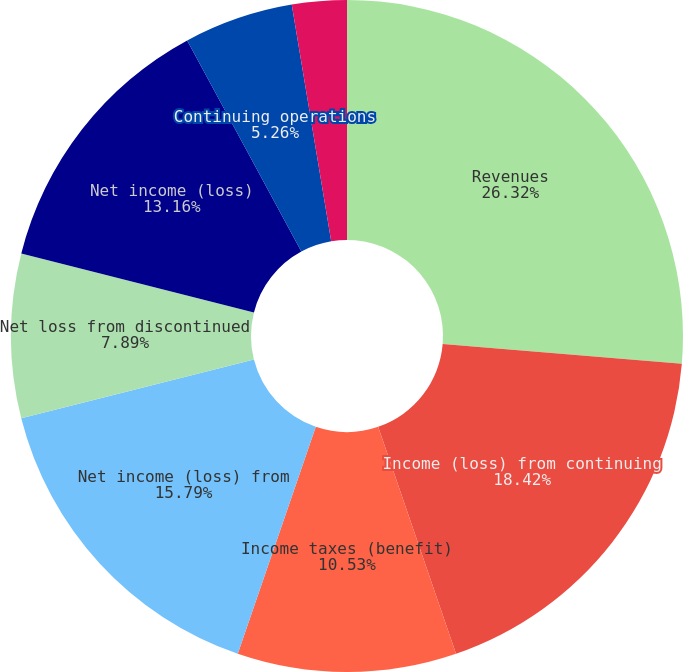Convert chart to OTSL. <chart><loc_0><loc_0><loc_500><loc_500><pie_chart><fcel>Revenues<fcel>Income (loss) from continuing<fcel>Income taxes (benefit)<fcel>Net income (loss) from<fcel>Net loss from discontinued<fcel>Net income (loss)<fcel>Continuing operations<fcel>Discontinued operations<fcel>Consolidated<nl><fcel>26.32%<fcel>18.42%<fcel>10.53%<fcel>15.79%<fcel>7.89%<fcel>13.16%<fcel>5.26%<fcel>0.0%<fcel>2.63%<nl></chart> 